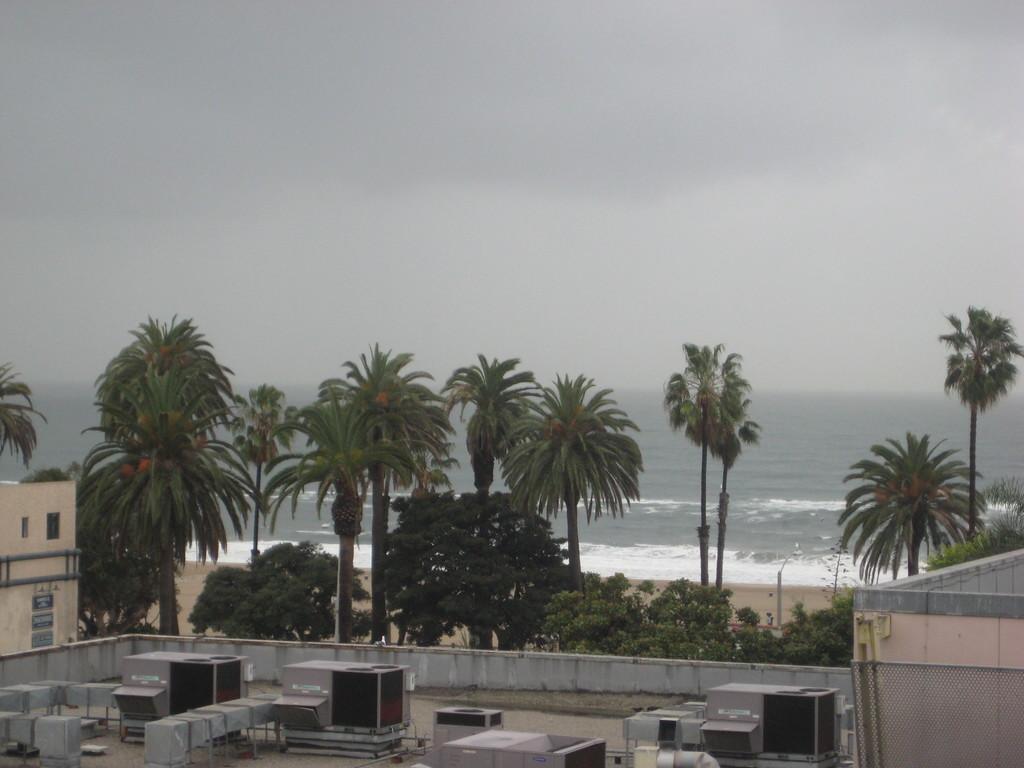Please provide a concise description of this image. In this image in front there are some objects. There is a wall. On both right and left side of the image there are buildings. In the background of the image there are trees, water and sky. 